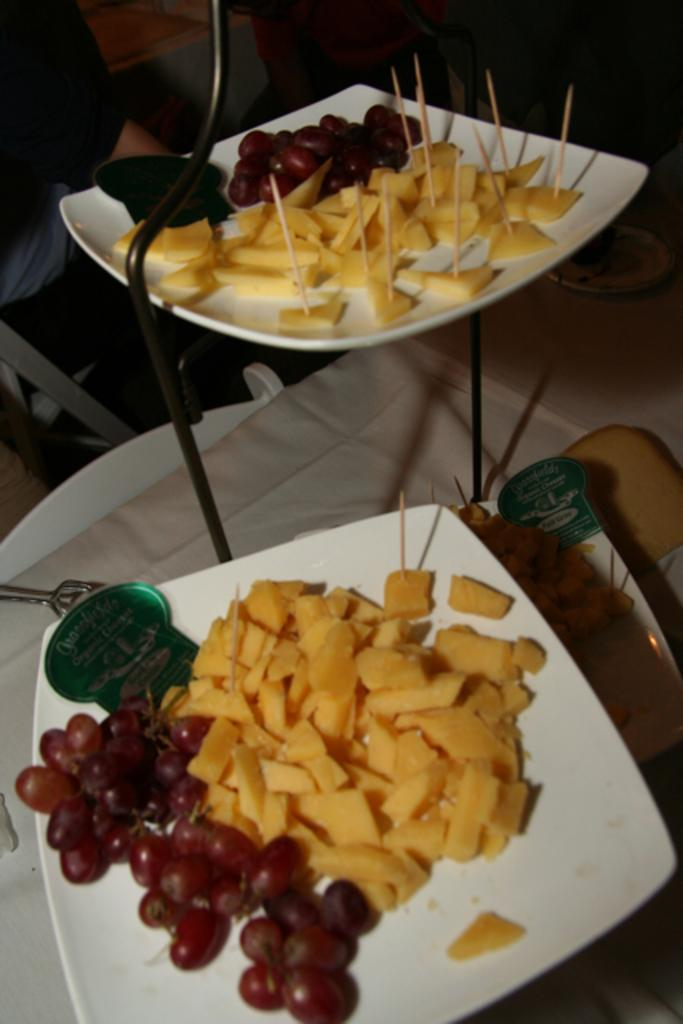Where was the image taken? The image is taken indoors. What can be seen on the table in the image? There is a table with a table cloth, and plates with salads are on the table. Can you describe the man in the image? There is a man at the top of the image. What type of skate is the man using to move around in the image? There is no skate present in the image, and the man is not moving around. Can you describe the field where the man is playing in the image? There is no field present in the image, as it was taken indoors. What is the man writing on the table in the image? There is no indication that the man is a writer or that he is writing anything in the image. 